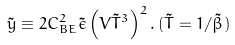<formula> <loc_0><loc_0><loc_500><loc_500>\tilde { y } \equiv 2 C ^ { 2 } _ { B E } \tilde { \epsilon } \left ( V \tilde { T } ^ { 3 } \right ) ^ { 2 } . \, ( \tilde { T } = 1 / \tilde { \beta } )</formula> 